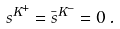Convert formula to latex. <formula><loc_0><loc_0><loc_500><loc_500>s ^ { K ^ { + } } = \bar { s } ^ { K ^ { - } } = 0 \, .</formula> 